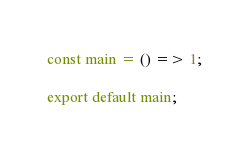<code> <loc_0><loc_0><loc_500><loc_500><_JavaScript_>const main = () => 1;

export default main;
</code> 